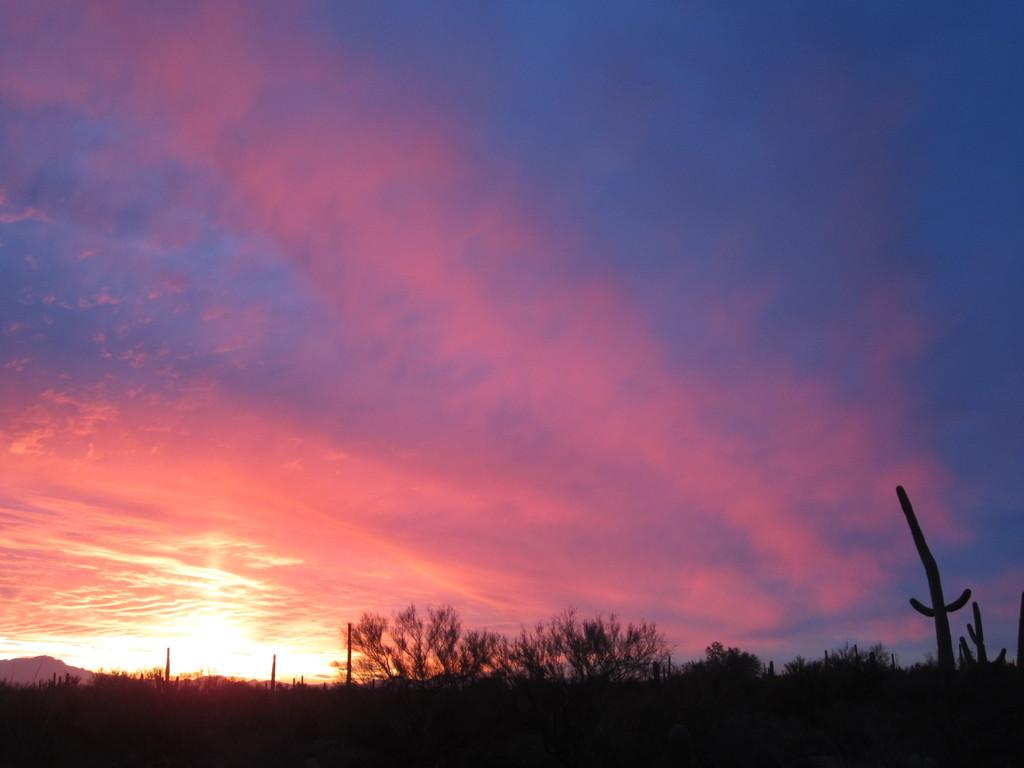What type of vegetation can be seen in the image? There are trees in the image. What is visible at the top of the image? The sky is visible at the top of the image. What can be observed in the sky? Clouds are present in the sky. How would you describe the overall lighting in the image? The image appears to be slightly dark. How much debt is the toad in the image carrying? There is no toad present in the image, and therefore no debt can be associated with it. 